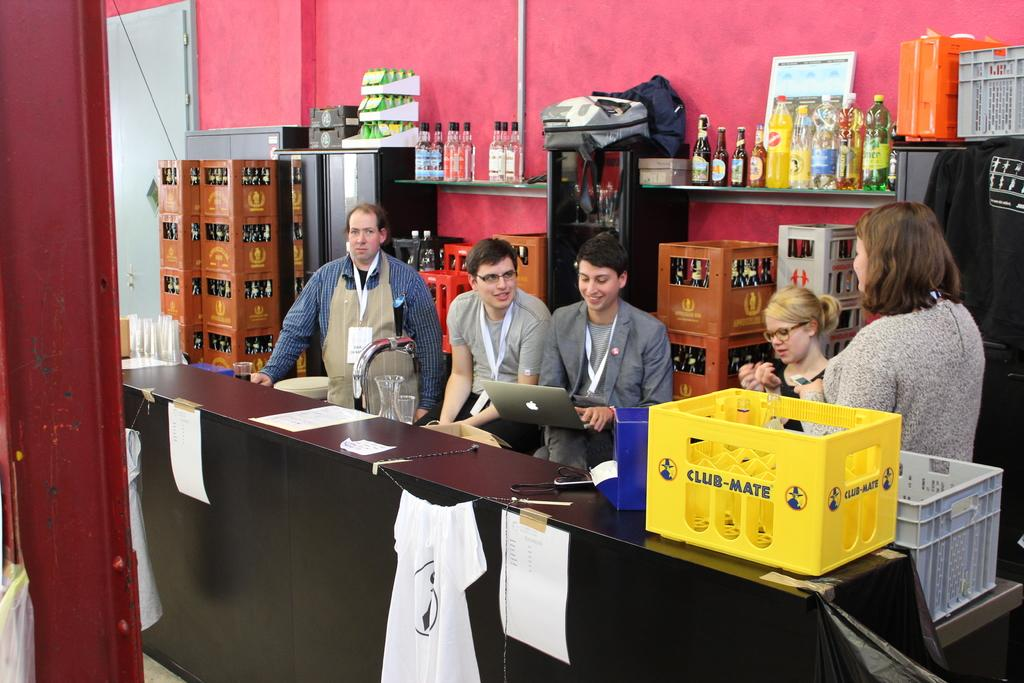<image>
Share a concise interpretation of the image provided. A yellow crate that says Club-Mate sits on a counter in front of several people. 